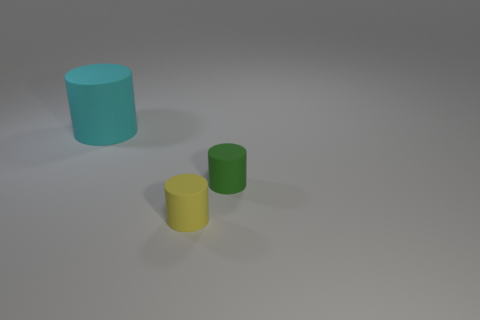Add 3 big rubber cylinders. How many objects exist? 6 Add 1 yellow matte things. How many yellow matte things are left? 2 Add 3 cyan rubber things. How many cyan rubber things exist? 4 Subtract 1 yellow cylinders. How many objects are left? 2 Subtract all cylinders. Subtract all blue cubes. How many objects are left? 0 